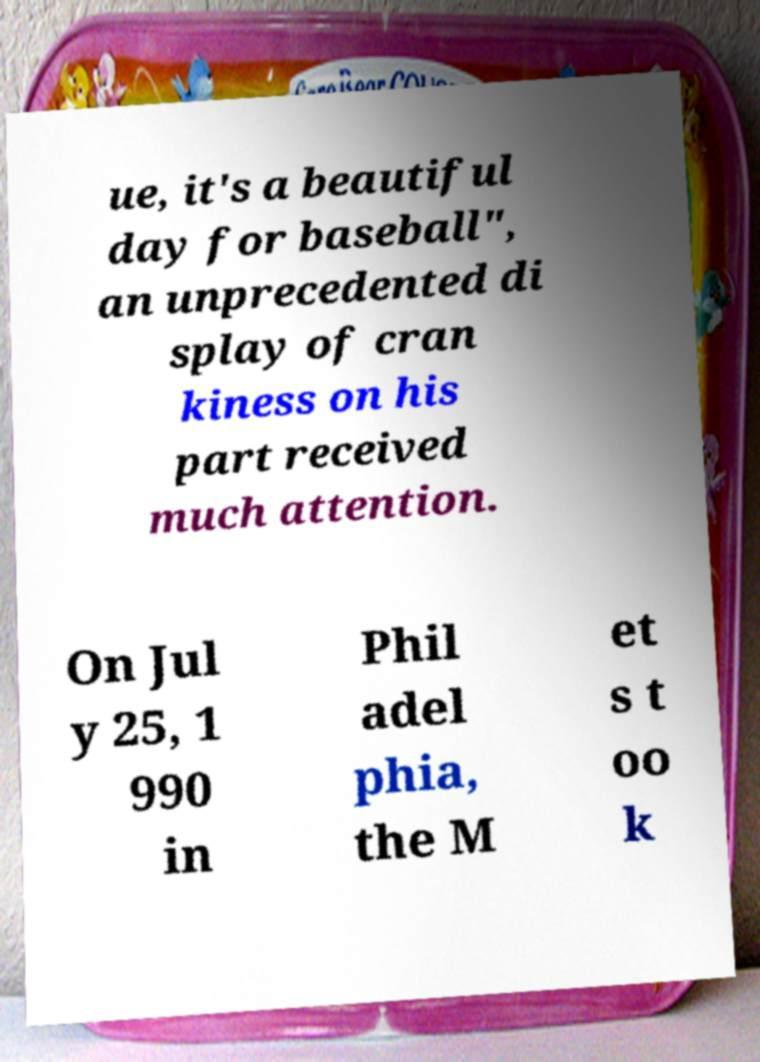Can you read and provide the text displayed in the image?This photo seems to have some interesting text. Can you extract and type it out for me? ue, it's a beautiful day for baseball", an unprecedented di splay of cran kiness on his part received much attention. On Jul y 25, 1 990 in Phil adel phia, the M et s t oo k 